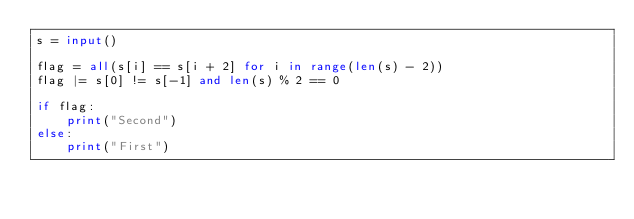Convert code to text. <code><loc_0><loc_0><loc_500><loc_500><_Python_>s = input()

flag = all(s[i] == s[i + 2] for i in range(len(s) - 2))
flag |= s[0] != s[-1] and len(s) % 2 == 0

if flag:
    print("Second")
else:
    print("First")
</code> 